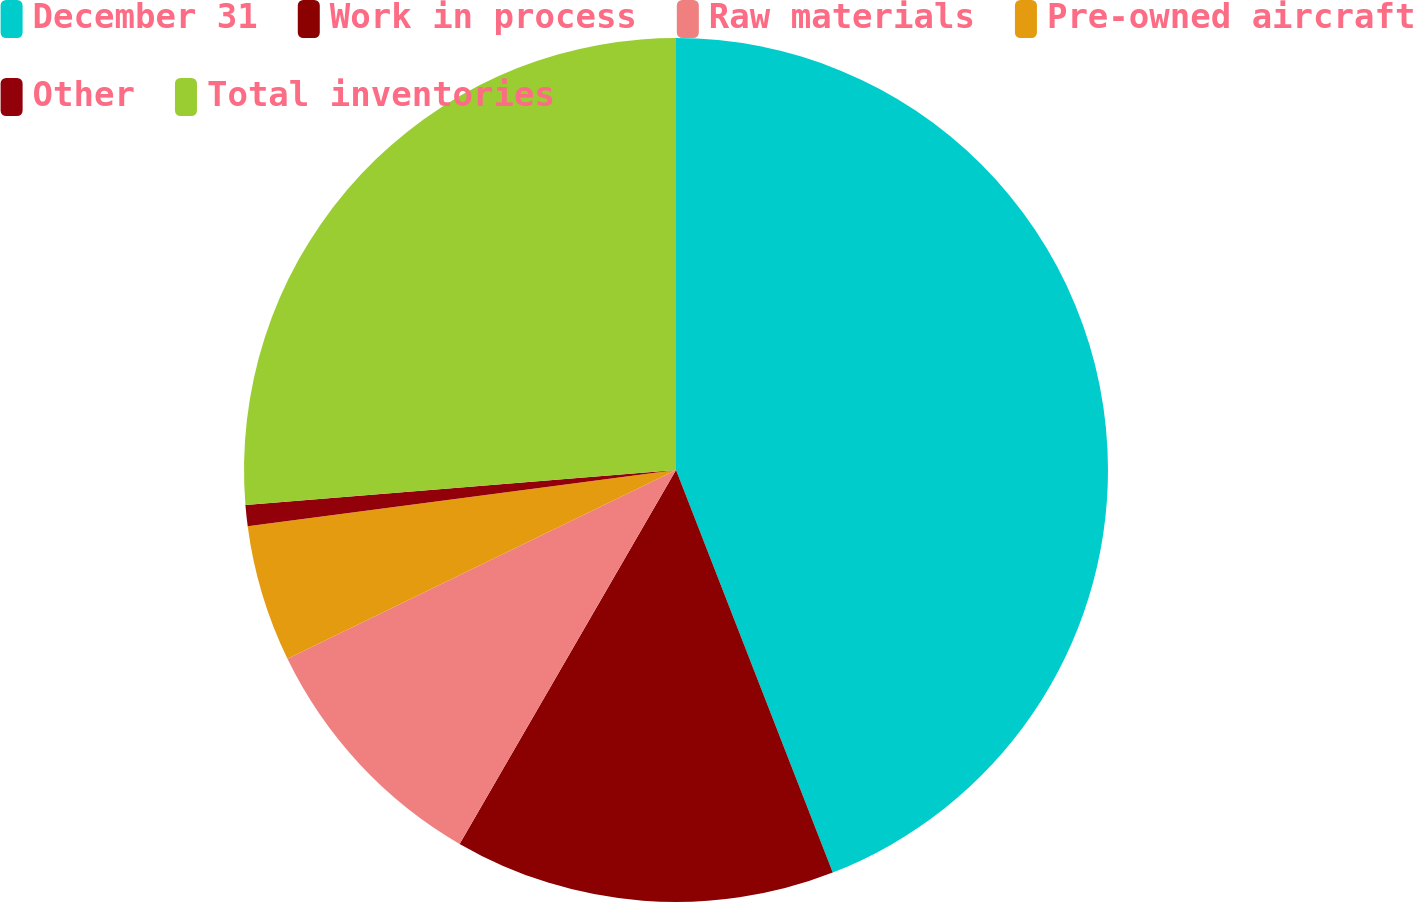<chart> <loc_0><loc_0><loc_500><loc_500><pie_chart><fcel>December 31<fcel>Work in process<fcel>Raw materials<fcel>Pre-owned aircraft<fcel>Other<fcel>Total inventories<nl><fcel>44.09%<fcel>14.26%<fcel>9.45%<fcel>5.12%<fcel>0.79%<fcel>26.29%<nl></chart> 